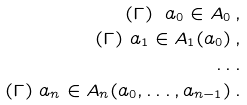<formula> <loc_0><loc_0><loc_500><loc_500>( \Gamma ) \ a _ { 0 } \in A _ { 0 } \, , \\ ( \Gamma ) \ a _ { 1 } \in A _ { 1 } ( a _ { 0 } ) \, , \\ \dots \\ ( \Gamma ) \ a _ { n } \in A _ { n } ( a _ { 0 } , \dots , a _ { n - 1 } ) \, .</formula> 